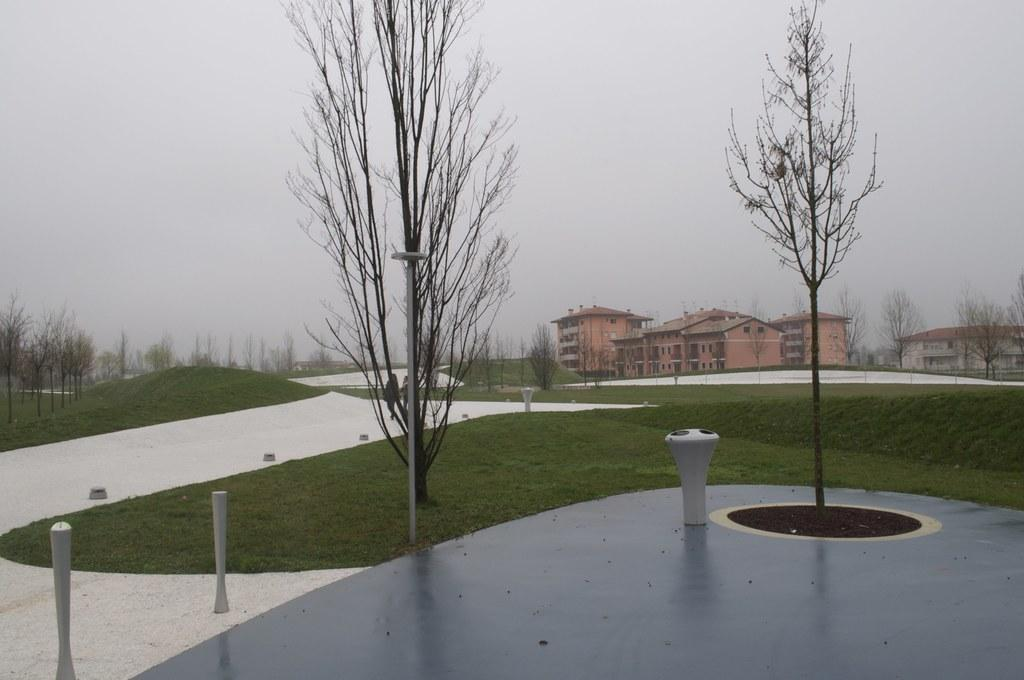What type of structures can be seen in the image? There are buildings in the image. What natural elements are present in the image? There are trees and grass in the image. What is the path used for in the image? The path is likely used for walking or traveling between the buildings and trees. What are the barrier rods used for in the image? The barrier rods might be used to separate or protect certain areas in the image. What can be seen in the background of the image? The sky is visible in the background of the image. What type of store can be seen in the image? There is no store present in the image. How many birds are visible in the image? There are no birds visible in the image. 